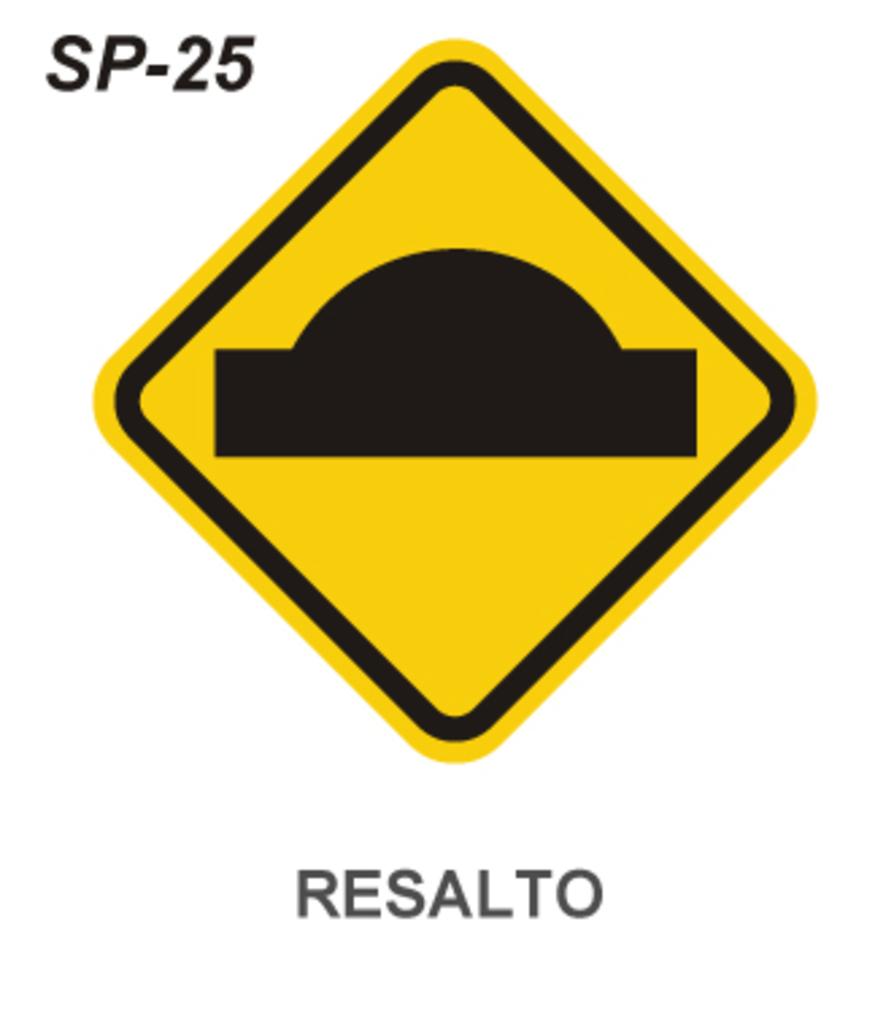Is this in english?
Ensure brevity in your answer.  No. 